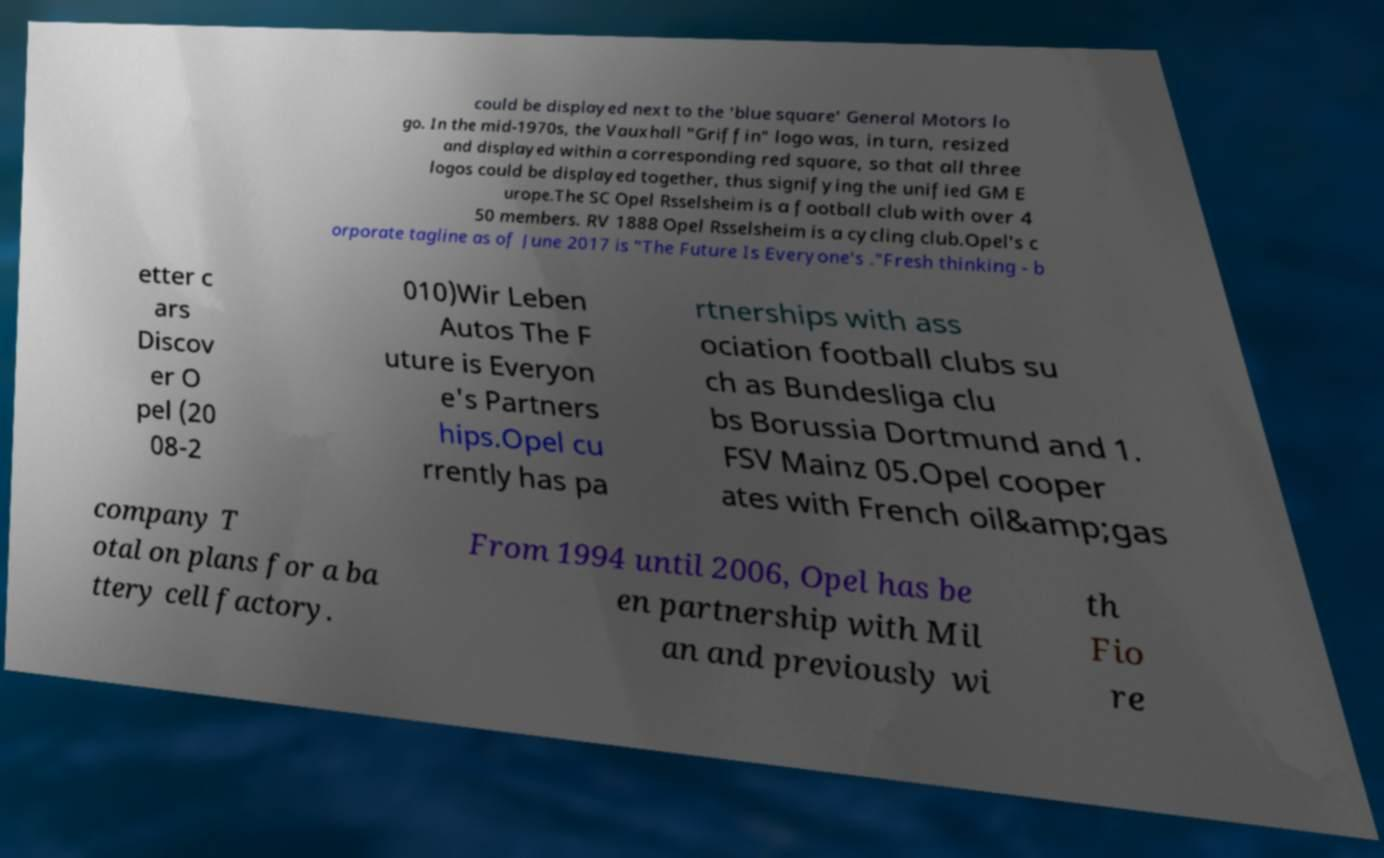I need the written content from this picture converted into text. Can you do that? could be displayed next to the 'blue square' General Motors lo go. In the mid-1970s, the Vauxhall "Griffin" logo was, in turn, resized and displayed within a corresponding red square, so that all three logos could be displayed together, thus signifying the unified GM E urope.The SC Opel Rsselsheim is a football club with over 4 50 members. RV 1888 Opel Rsselsheim is a cycling club.Opel's c orporate tagline as of June 2017 is "The Future Is Everyone's ."Fresh thinking - b etter c ars Discov er O pel (20 08-2 010)Wir Leben Autos The F uture is Everyon e's Partners hips.Opel cu rrently has pa rtnerships with ass ociation football clubs su ch as Bundesliga clu bs Borussia Dortmund and 1. FSV Mainz 05.Opel cooper ates with French oil&amp;gas company T otal on plans for a ba ttery cell factory. From 1994 until 2006, Opel has be en partnership with Mil an and previously wi th Fio re 